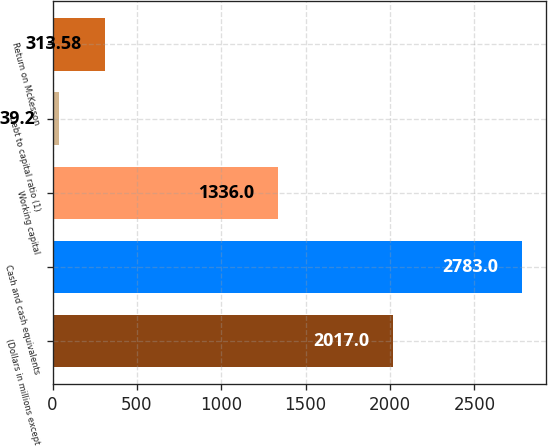Convert chart. <chart><loc_0><loc_0><loc_500><loc_500><bar_chart><fcel>(Dollars in millions except<fcel>Cash and cash equivalents<fcel>Working capital<fcel>Debt to capital ratio (1)<fcel>Return on McKesson<nl><fcel>2017<fcel>2783<fcel>1336<fcel>39.2<fcel>313.58<nl></chart> 